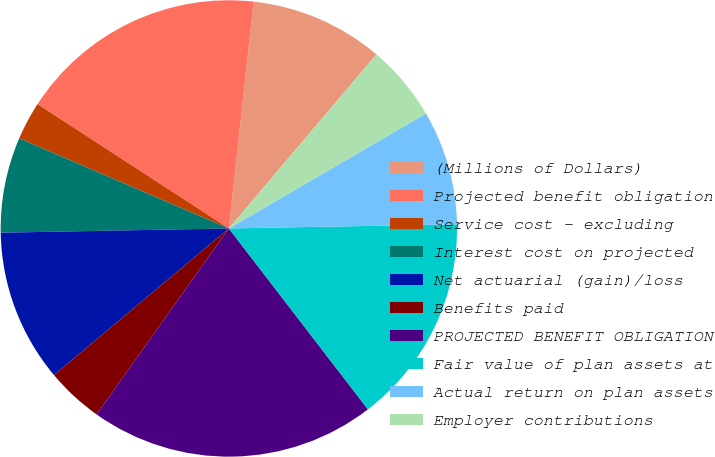Convert chart. <chart><loc_0><loc_0><loc_500><loc_500><pie_chart><fcel>(Millions of Dollars)<fcel>Projected benefit obligation<fcel>Service cost - excluding<fcel>Interest cost on projected<fcel>Net actuarial (gain)/loss<fcel>Benefits paid<fcel>PROJECTED BENEFIT OBLIGATION<fcel>Fair value of plan assets at<fcel>Actual return on plan assets<fcel>Employer contributions<nl><fcel>9.46%<fcel>17.56%<fcel>2.71%<fcel>6.76%<fcel>10.81%<fcel>4.06%<fcel>20.27%<fcel>14.86%<fcel>8.11%<fcel>5.41%<nl></chart> 